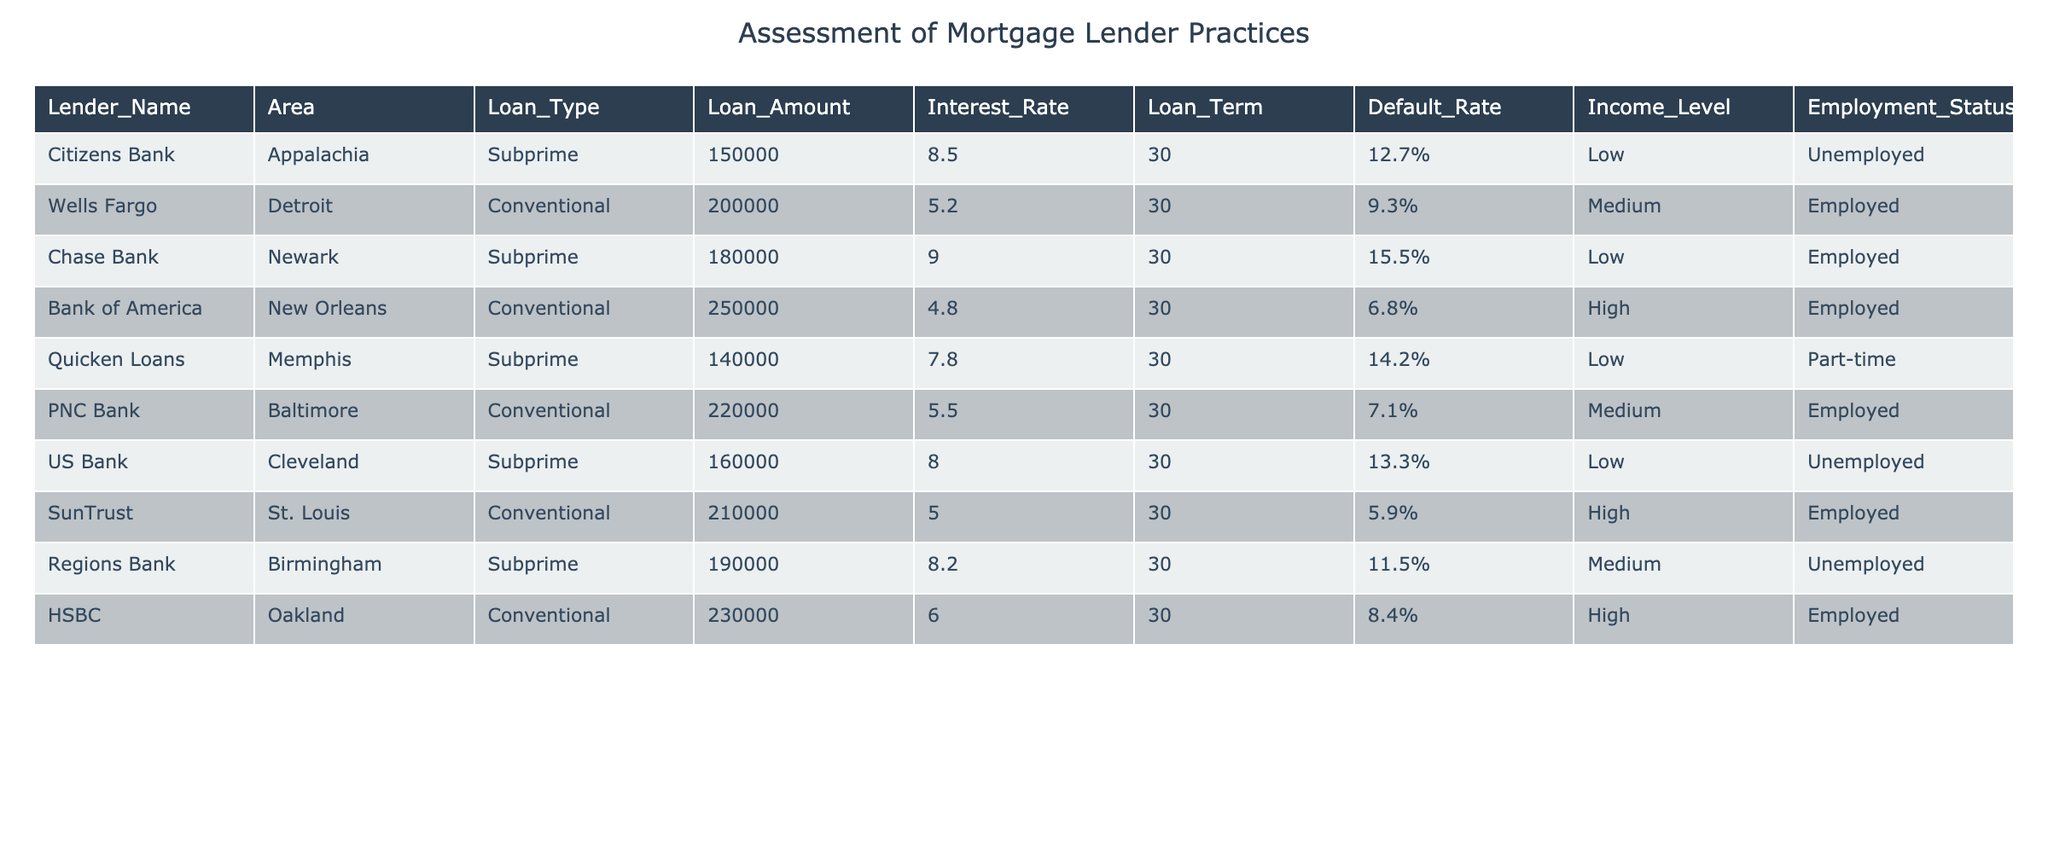What is the highest default rate among the lenders listed? The default rate for each lender is presented in the "Default Rate" column. By identifying the maximum value from that column, we find that Chase Bank has the highest default rate at 15.5%.
Answer: 15.5% Which lender in a high-income area has the lowest default rate? The loans from high-income areas in the table are provided by Bank of America and SunTrust. Their respective default rates are 6.8% and 5.9%. SunTrust has the lowest default rate at 5.9%.
Answer: 5.9% What is the average loan amount for subprime loans? The subprime loans listed in the table are from Citizens Bank, Chase Bank, Quicken Loans, US Bank, and Regions Bank. Their loan amounts are 150000, 180000, 140000, 160000, and 190000 respectively. The sum of these amounts is 820000. Dividing by the number of loans (5), we find the average loan amount is 164000.
Answer: 164000 Is there any lender that provides subprime loans with an employed borrower? By examining the table, we find that Chase Bank has subprime loans provided to an employed borrower, specifically cited in the "Employment Status" column.
Answer: Yes What is the difference in interest rates between the highest and lowest subprime loans? The subprime loans have interest rates of 8.5%, 9.0%, 7.8%, 8.0%, and 8.2%. The highest rate is 9.0% (Chase Bank) and the lowest is 7.8% (Quicken Loans). The difference is 9.0% - 7.8% = 1.2%.
Answer: 1.2% Which lender has the lowest loan amount for subprime lending? By checking the "Loan Amount" column for subprime lenders, the amounts are 150000 (Citizens Bank), 180000 (Chase Bank), 140000 (Quicken Loans), 160000 (US Bank), and 190000 (Regions Bank). Quicken Loans has the lowest amount at 140000.
Answer: 140000 How many lenders have a default rate higher than 10%? The lenders with a default rate higher than 10% are Citizens Bank (12.7%), Chase Bank (15.5%), Quicken Loans (14.2%), and US Bank (13.3%). Counting these gives us a total of 4 lenders.
Answer: 4 What percentage of the total loans are subprime loans? The table lists a total of 8 loans, with 5 falling into the subprime category. To find the percentage, we calculate (5/8) * 100 = 62.5%.
Answer: 62.5% 